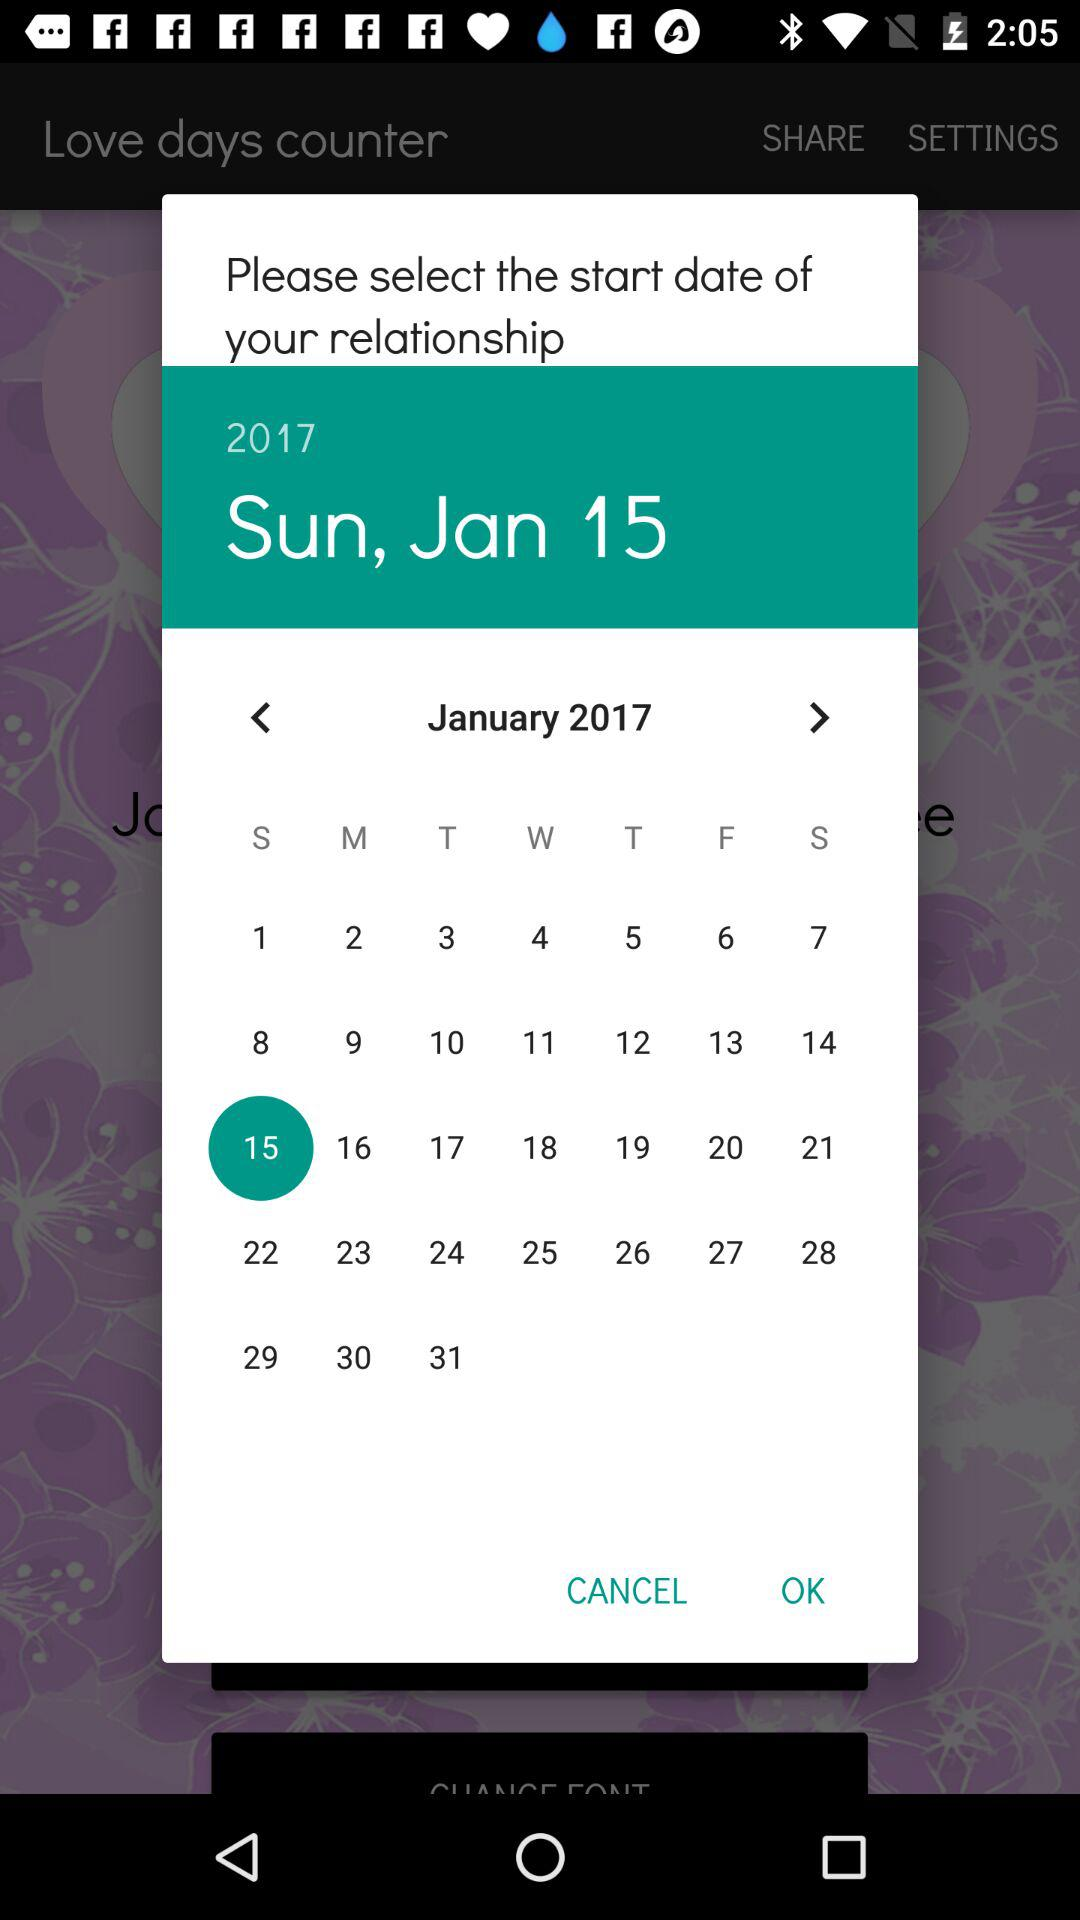Which date has been selected? The selected date is Sunday, January 15, 2017. 